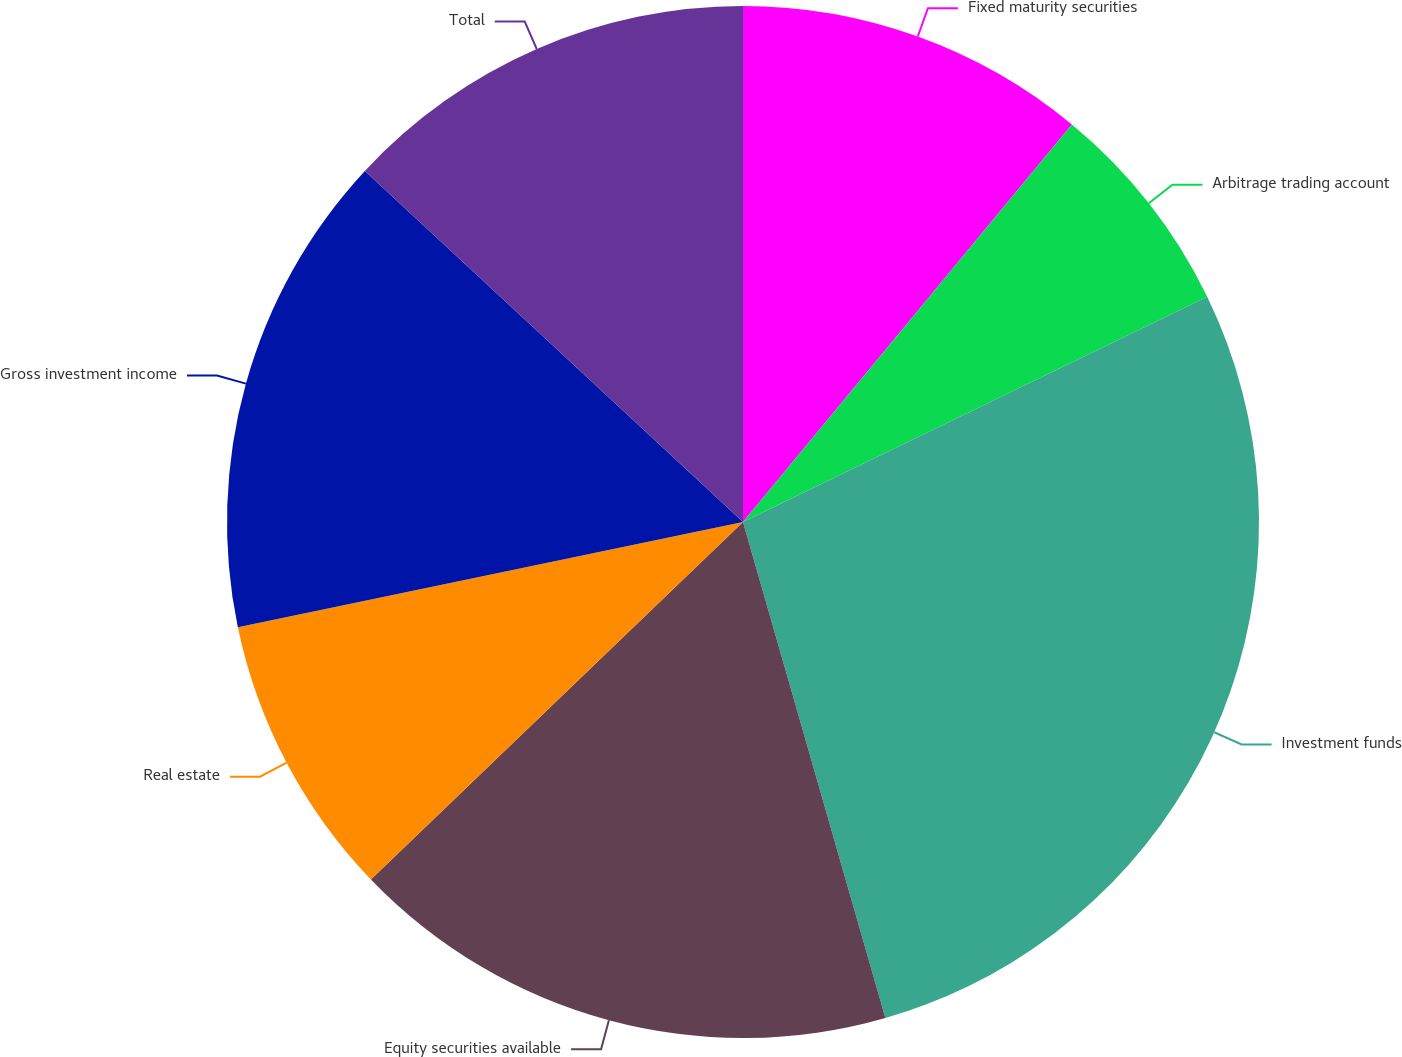Convert chart to OTSL. <chart><loc_0><loc_0><loc_500><loc_500><pie_chart><fcel>Fixed maturity securities<fcel>Arbitrage trading account<fcel>Investment funds<fcel>Equity securities available<fcel>Real estate<fcel>Gross investment income<fcel>Total<nl><fcel>11.0%<fcel>6.81%<fcel>27.74%<fcel>17.27%<fcel>8.91%<fcel>15.18%<fcel>13.09%<nl></chart> 